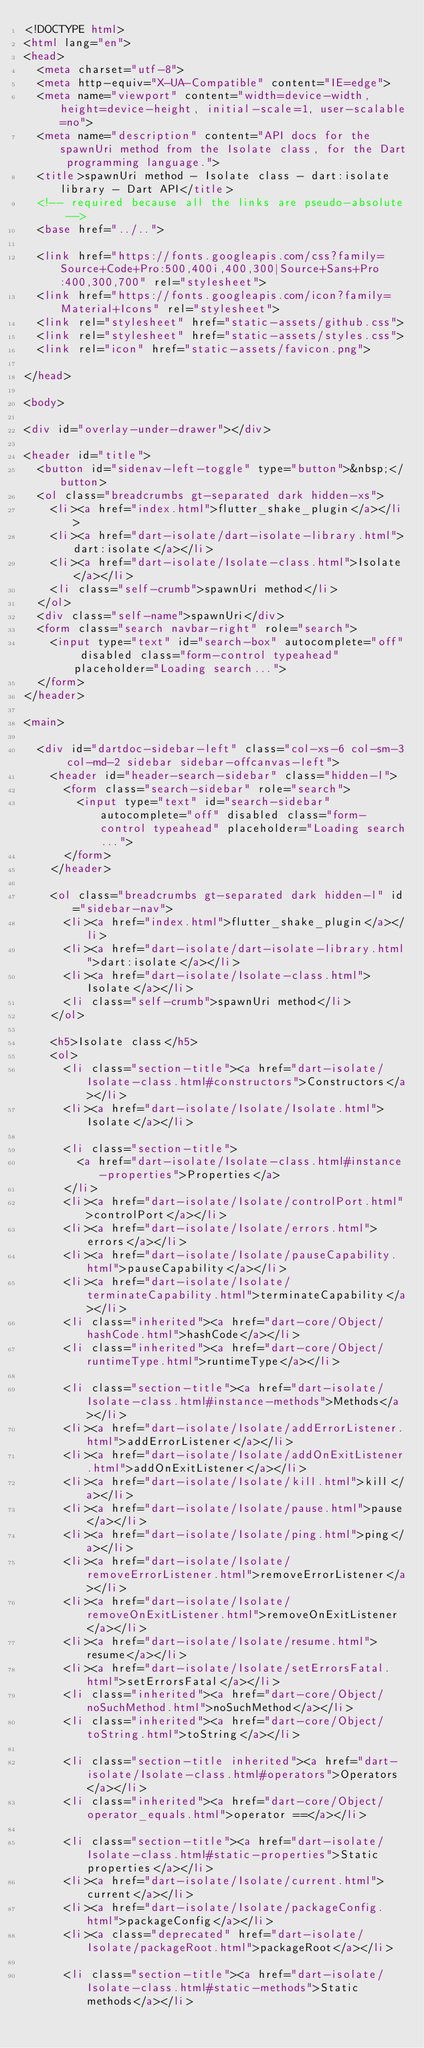Convert code to text. <code><loc_0><loc_0><loc_500><loc_500><_HTML_><!DOCTYPE html>
<html lang="en">
<head>
  <meta charset="utf-8">
  <meta http-equiv="X-UA-Compatible" content="IE=edge">
  <meta name="viewport" content="width=device-width, height=device-height, initial-scale=1, user-scalable=no">
  <meta name="description" content="API docs for the spawnUri method from the Isolate class, for the Dart programming language.">
  <title>spawnUri method - Isolate class - dart:isolate library - Dart API</title>
  <!-- required because all the links are pseudo-absolute -->
  <base href="../..">

  <link href="https://fonts.googleapis.com/css?family=Source+Code+Pro:500,400i,400,300|Source+Sans+Pro:400,300,700" rel="stylesheet">
  <link href="https://fonts.googleapis.com/icon?family=Material+Icons" rel="stylesheet">
  <link rel="stylesheet" href="static-assets/github.css">
  <link rel="stylesheet" href="static-assets/styles.css">
  <link rel="icon" href="static-assets/favicon.png">
  
</head>

<body>

<div id="overlay-under-drawer"></div>

<header id="title">
  <button id="sidenav-left-toggle" type="button">&nbsp;</button>
  <ol class="breadcrumbs gt-separated dark hidden-xs">
    <li><a href="index.html">flutter_shake_plugin</a></li>
    <li><a href="dart-isolate/dart-isolate-library.html">dart:isolate</a></li>
    <li><a href="dart-isolate/Isolate-class.html">Isolate</a></li>
    <li class="self-crumb">spawnUri method</li>
  </ol>
  <div class="self-name">spawnUri</div>
  <form class="search navbar-right" role="search">
    <input type="text" id="search-box" autocomplete="off" disabled class="form-control typeahead" placeholder="Loading search...">
  </form>
</header>

<main>

  <div id="dartdoc-sidebar-left" class="col-xs-6 col-sm-3 col-md-2 sidebar sidebar-offcanvas-left">
    <header id="header-search-sidebar" class="hidden-l">
      <form class="search-sidebar" role="search">
        <input type="text" id="search-sidebar" autocomplete="off" disabled class="form-control typeahead" placeholder="Loading search...">
      </form>
    </header>
    
    <ol class="breadcrumbs gt-separated dark hidden-l" id="sidebar-nav">
      <li><a href="index.html">flutter_shake_plugin</a></li>
      <li><a href="dart-isolate/dart-isolate-library.html">dart:isolate</a></li>
      <li><a href="dart-isolate/Isolate-class.html">Isolate</a></li>
      <li class="self-crumb">spawnUri method</li>
    </ol>
    
    <h5>Isolate class</h5>
    <ol>
      <li class="section-title"><a href="dart-isolate/Isolate-class.html#constructors">Constructors</a></li>
      <li><a href="dart-isolate/Isolate/Isolate.html">Isolate</a></li>
    
      <li class="section-title">
        <a href="dart-isolate/Isolate-class.html#instance-properties">Properties</a>
      </li>
      <li><a href="dart-isolate/Isolate/controlPort.html">controlPort</a></li>
      <li><a href="dart-isolate/Isolate/errors.html">errors</a></li>
      <li><a href="dart-isolate/Isolate/pauseCapability.html">pauseCapability</a></li>
      <li><a href="dart-isolate/Isolate/terminateCapability.html">terminateCapability</a></li>
      <li class="inherited"><a href="dart-core/Object/hashCode.html">hashCode</a></li>
      <li class="inherited"><a href="dart-core/Object/runtimeType.html">runtimeType</a></li>
    
      <li class="section-title"><a href="dart-isolate/Isolate-class.html#instance-methods">Methods</a></li>
      <li><a href="dart-isolate/Isolate/addErrorListener.html">addErrorListener</a></li>
      <li><a href="dart-isolate/Isolate/addOnExitListener.html">addOnExitListener</a></li>
      <li><a href="dart-isolate/Isolate/kill.html">kill</a></li>
      <li><a href="dart-isolate/Isolate/pause.html">pause</a></li>
      <li><a href="dart-isolate/Isolate/ping.html">ping</a></li>
      <li><a href="dart-isolate/Isolate/removeErrorListener.html">removeErrorListener</a></li>
      <li><a href="dart-isolate/Isolate/removeOnExitListener.html">removeOnExitListener</a></li>
      <li><a href="dart-isolate/Isolate/resume.html">resume</a></li>
      <li><a href="dart-isolate/Isolate/setErrorsFatal.html">setErrorsFatal</a></li>
      <li class="inherited"><a href="dart-core/Object/noSuchMethod.html">noSuchMethod</a></li>
      <li class="inherited"><a href="dart-core/Object/toString.html">toString</a></li>
    
      <li class="section-title inherited"><a href="dart-isolate/Isolate-class.html#operators">Operators</a></li>
      <li class="inherited"><a href="dart-core/Object/operator_equals.html">operator ==</a></li>
    
      <li class="section-title"><a href="dart-isolate/Isolate-class.html#static-properties">Static properties</a></li>
      <li><a href="dart-isolate/Isolate/current.html">current</a></li>
      <li><a href="dart-isolate/Isolate/packageConfig.html">packageConfig</a></li>
      <li><a class="deprecated" href="dart-isolate/Isolate/packageRoot.html">packageRoot</a></li>
    
      <li class="section-title"><a href="dart-isolate/Isolate-class.html#static-methods">Static methods</a></li></code> 